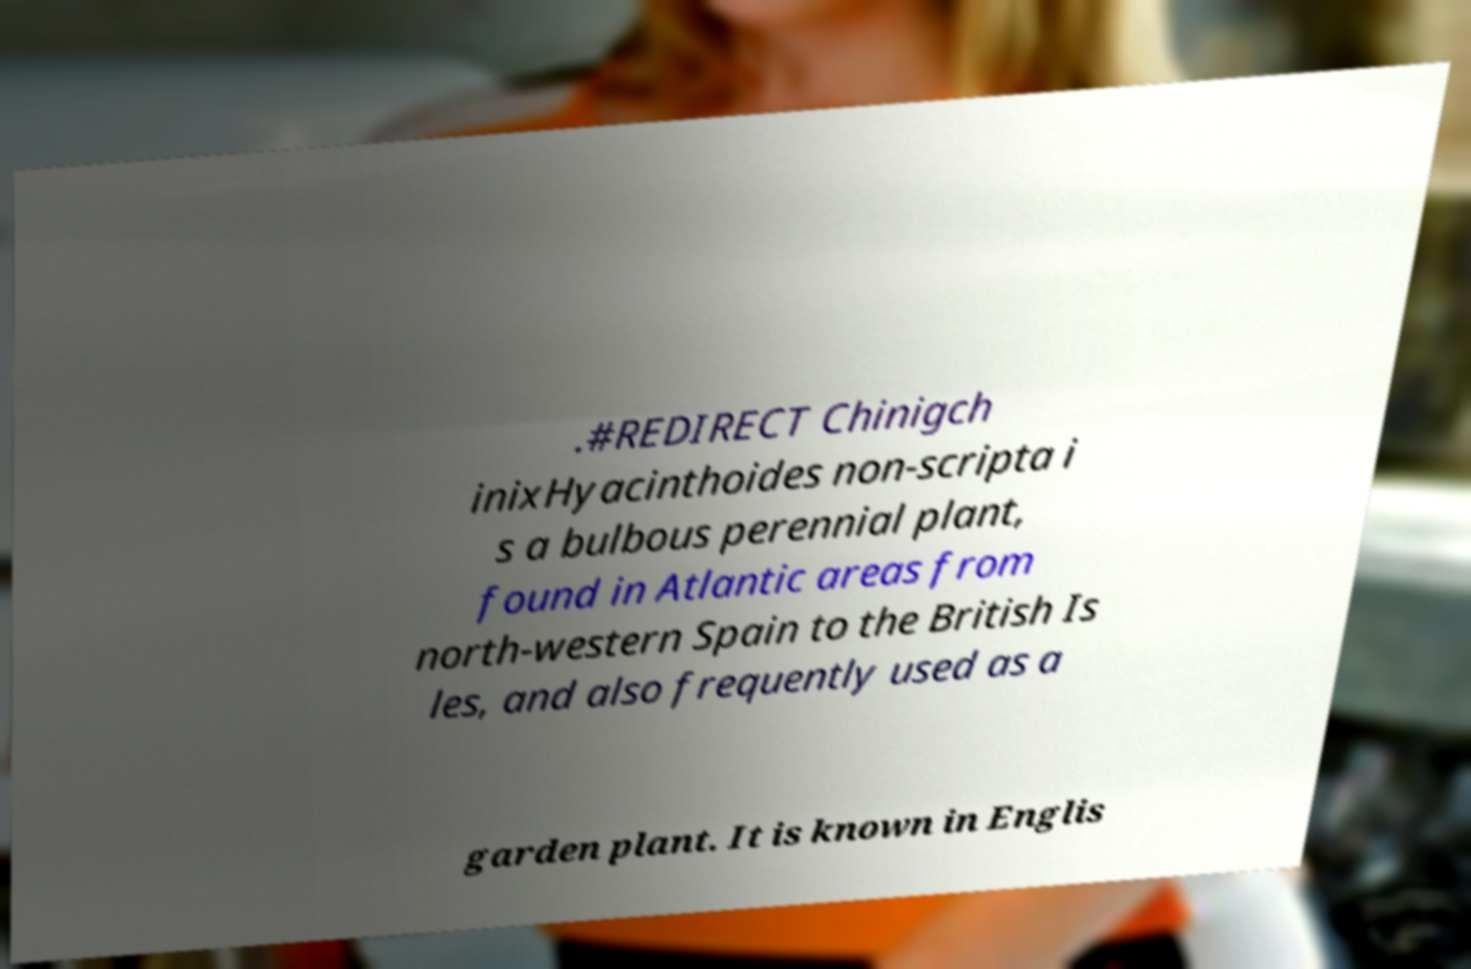Could you assist in decoding the text presented in this image and type it out clearly? .#REDIRECT Chinigch inixHyacinthoides non-scripta i s a bulbous perennial plant, found in Atlantic areas from north-western Spain to the British Is les, and also frequently used as a garden plant. It is known in Englis 